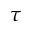Convert formula to latex. <formula><loc_0><loc_0><loc_500><loc_500>\tau</formula> 